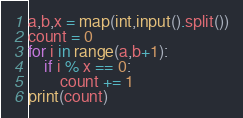<code> <loc_0><loc_0><loc_500><loc_500><_Python_>
a,b,x = map(int,input().split())
count = 0
for i in range(a,b+1):
    if i % x == 0:
        count += 1
print(count)</code> 